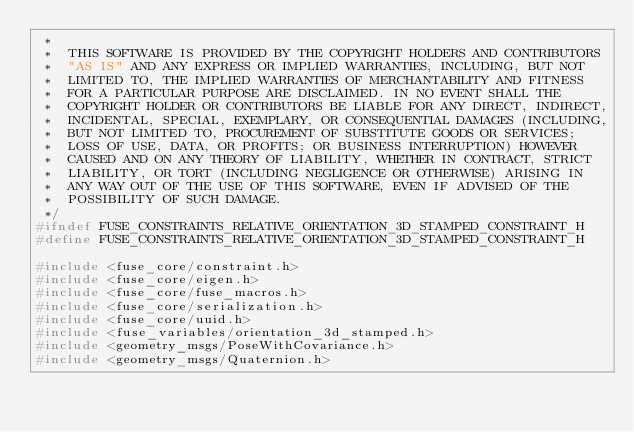<code> <loc_0><loc_0><loc_500><loc_500><_C_> *
 *  THIS SOFTWARE IS PROVIDED BY THE COPYRIGHT HOLDERS AND CONTRIBUTORS
 *  "AS IS" AND ANY EXPRESS OR IMPLIED WARRANTIES, INCLUDING, BUT NOT
 *  LIMITED TO, THE IMPLIED WARRANTIES OF MERCHANTABILITY AND FITNESS
 *  FOR A PARTICULAR PURPOSE ARE DISCLAIMED. IN NO EVENT SHALL THE
 *  COPYRIGHT HOLDER OR CONTRIBUTORS BE LIABLE FOR ANY DIRECT, INDIRECT,
 *  INCIDENTAL, SPECIAL, EXEMPLARY, OR CONSEQUENTIAL DAMAGES (INCLUDING,
 *  BUT NOT LIMITED TO, PROCUREMENT OF SUBSTITUTE GOODS OR SERVICES;
 *  LOSS OF USE, DATA, OR PROFITS; OR BUSINESS INTERRUPTION) HOWEVER
 *  CAUSED AND ON ANY THEORY OF LIABILITY, WHETHER IN CONTRACT, STRICT
 *  LIABILITY, OR TORT (INCLUDING NEGLIGENCE OR OTHERWISE) ARISING IN
 *  ANY WAY OUT OF THE USE OF THIS SOFTWARE, EVEN IF ADVISED OF THE
 *  POSSIBILITY OF SUCH DAMAGE.
 */
#ifndef FUSE_CONSTRAINTS_RELATIVE_ORIENTATION_3D_STAMPED_CONSTRAINT_H
#define FUSE_CONSTRAINTS_RELATIVE_ORIENTATION_3D_STAMPED_CONSTRAINT_H

#include <fuse_core/constraint.h>
#include <fuse_core/eigen.h>
#include <fuse_core/fuse_macros.h>
#include <fuse_core/serialization.h>
#include <fuse_core/uuid.h>
#include <fuse_variables/orientation_3d_stamped.h>
#include <geometry_msgs/PoseWithCovariance.h>
#include <geometry_msgs/Quaternion.h>
</code> 